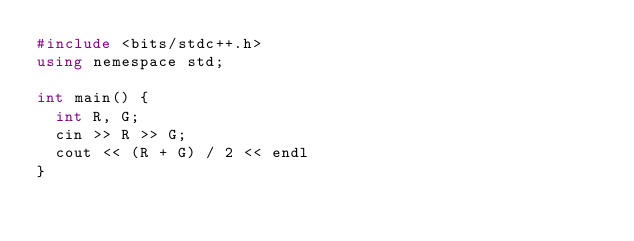<code> <loc_0><loc_0><loc_500><loc_500><_C++_>#include <bits/stdc++.h>
using nemespace std;

int main() {
  int R, G;
  cin >> R >> G;
  cout << (R + G) / 2 << endl
}</code> 